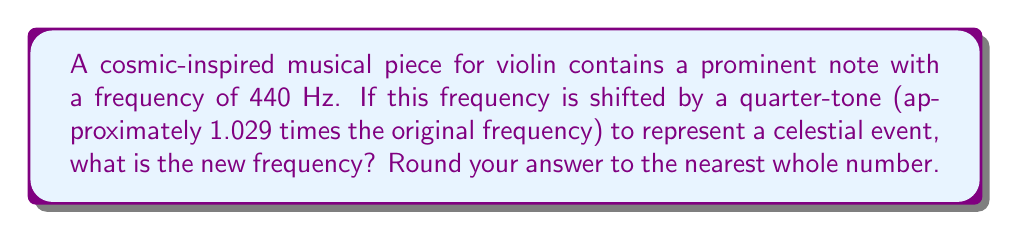Show me your answer to this math problem. To solve this problem, we'll follow these steps:

1) The original frequency is 440 Hz.

2) A quarter-tone shift is approximately 1.029 times the original frequency.

3) To calculate the new frequency, we multiply the original frequency by 1.029:

   $$f_{new} = f_{original} \times 1.029$$

4) Substituting the values:

   $$f_{new} = 440 \text{ Hz} \times 1.029$$

5) Calculating:

   $$f_{new} = 452.76 \text{ Hz}$$

6) Rounding to the nearest whole number:

   $$f_{new} \approx 453 \text{ Hz}$$

This shift in frequency could represent a subtle change in the music to evoke a cosmic event, such as a star's movement or a planetary alignment.
Answer: 453 Hz 